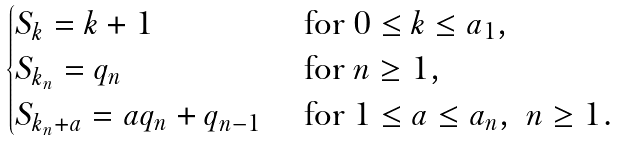<formula> <loc_0><loc_0><loc_500><loc_500>\begin{cases} S _ { k } = k + 1 & \text { for } 0 \leq k \leq a _ { 1 } , \\ S _ { k _ { n } } = q _ { n } & \text { for } n \geq 1 , \\ S _ { k _ { n } + a } = a q _ { n } + q _ { n - 1 } & \text { for } 1 \leq a \leq a _ { n } , \ n \geq 1 . \end{cases}</formula> 